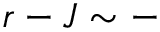Convert formula to latex. <formula><loc_0><loc_0><loc_500><loc_500>r - J \sim -</formula> 